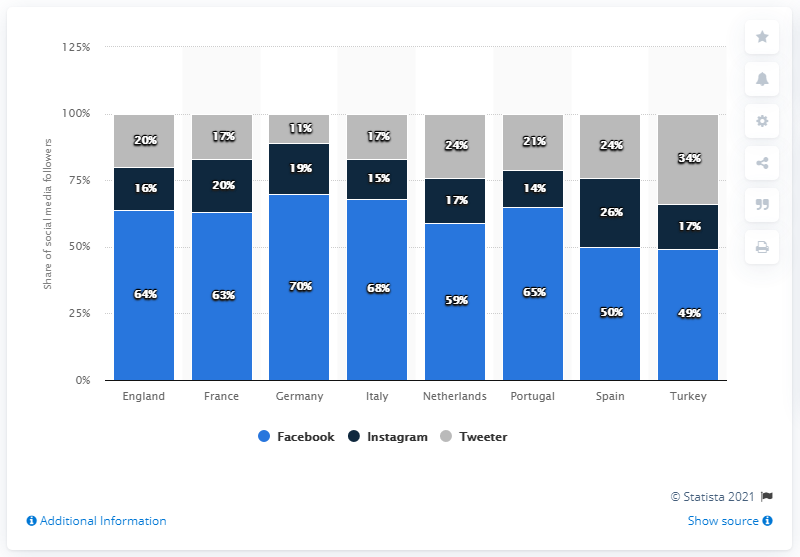Mention a couple of crucial points in this snapshot. According to a report, in 2018, Turkey had the largest share of Twitter followers among all countries. 